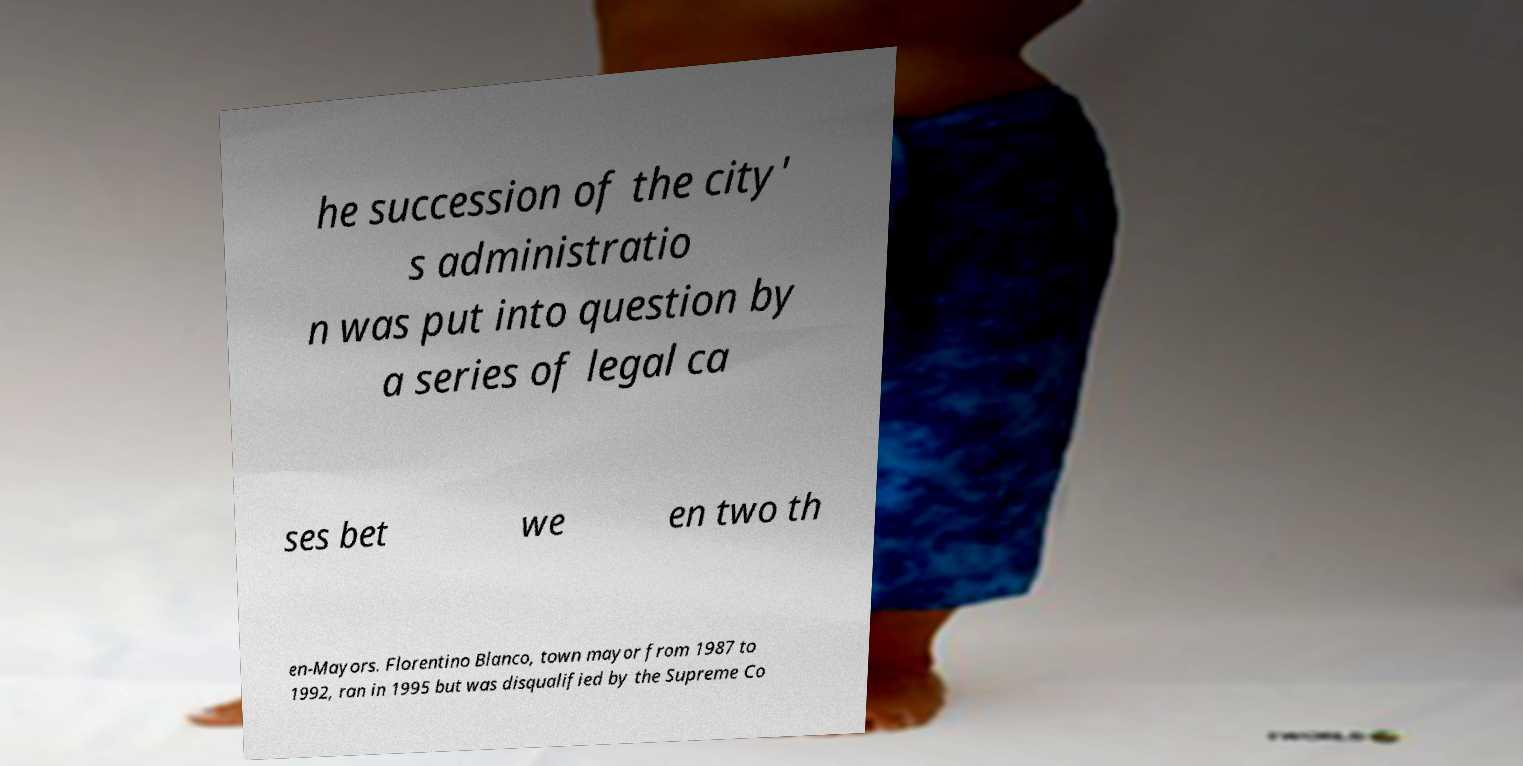There's text embedded in this image that I need extracted. Can you transcribe it verbatim? he succession of the city' s administratio n was put into question by a series of legal ca ses bet we en two th en-Mayors. Florentino Blanco, town mayor from 1987 to 1992, ran in 1995 but was disqualified by the Supreme Co 